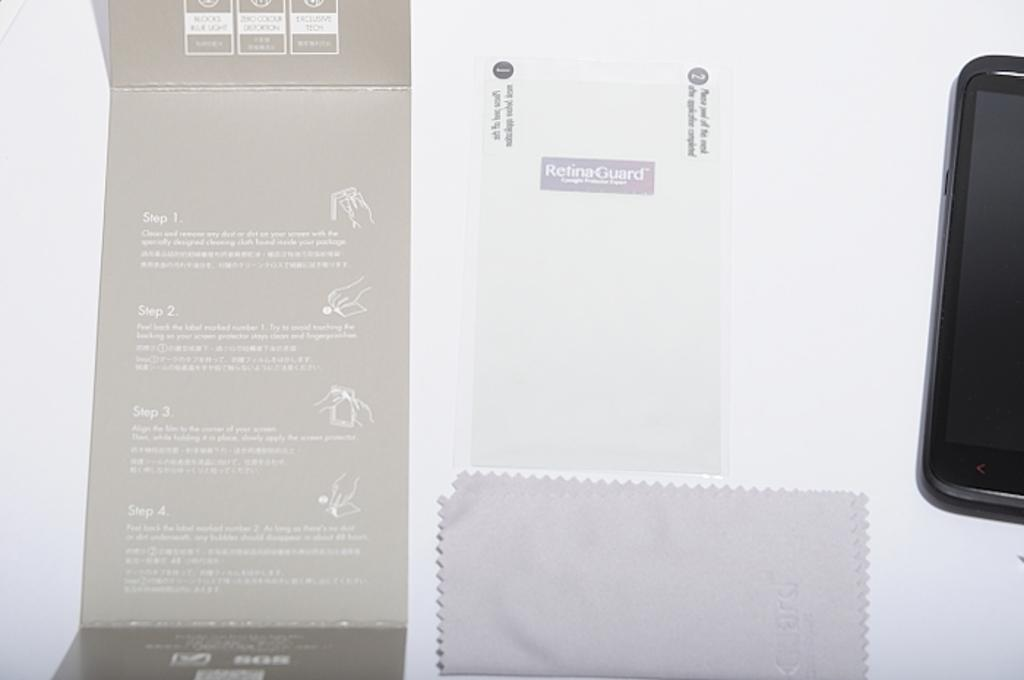What electronic device is visible in the image? There is a mobile phone in the image. What type of writing material is present in the image? There is a paper in the image. What fabric item can be seen in the image? There is a cloth in the image. What surface is the mobile phone, paper, and cloth placed on in the image? There is a board in the image. What color is the background of the image? The background of the image is white. What type of cake is being prepared in the image? There is no cake present in the image. How many toys are visible in the image? There are no toys visible in the image. 